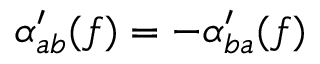Convert formula to latex. <formula><loc_0><loc_0><loc_500><loc_500>\alpha _ { a b } ^ { \prime } ( f ) = - \alpha _ { b a } ^ { \prime } ( f )</formula> 